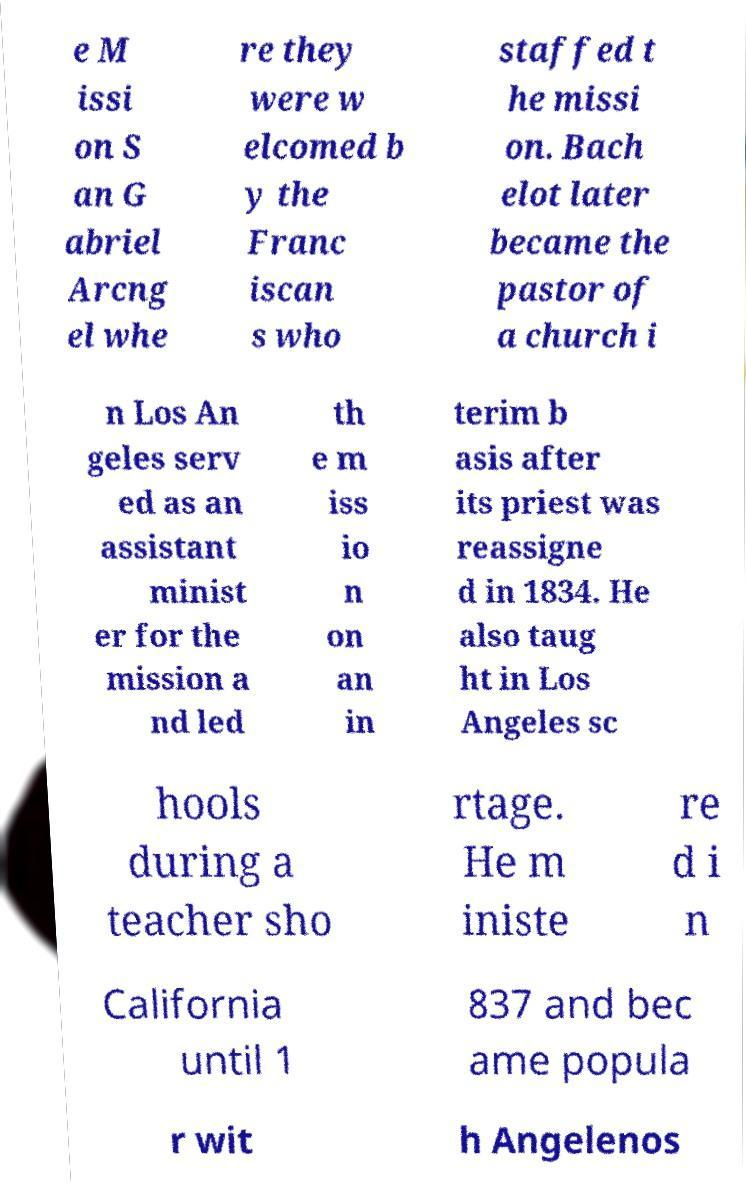Can you read and provide the text displayed in the image?This photo seems to have some interesting text. Can you extract and type it out for me? e M issi on S an G abriel Arcng el whe re they were w elcomed b y the Franc iscan s who staffed t he missi on. Bach elot later became the pastor of a church i n Los An geles serv ed as an assistant minist er for the mission a nd led th e m iss io n on an in terim b asis after its priest was reassigne d in 1834. He also taug ht in Los Angeles sc hools during a teacher sho rtage. He m iniste re d i n California until 1 837 and bec ame popula r wit h Angelenos 